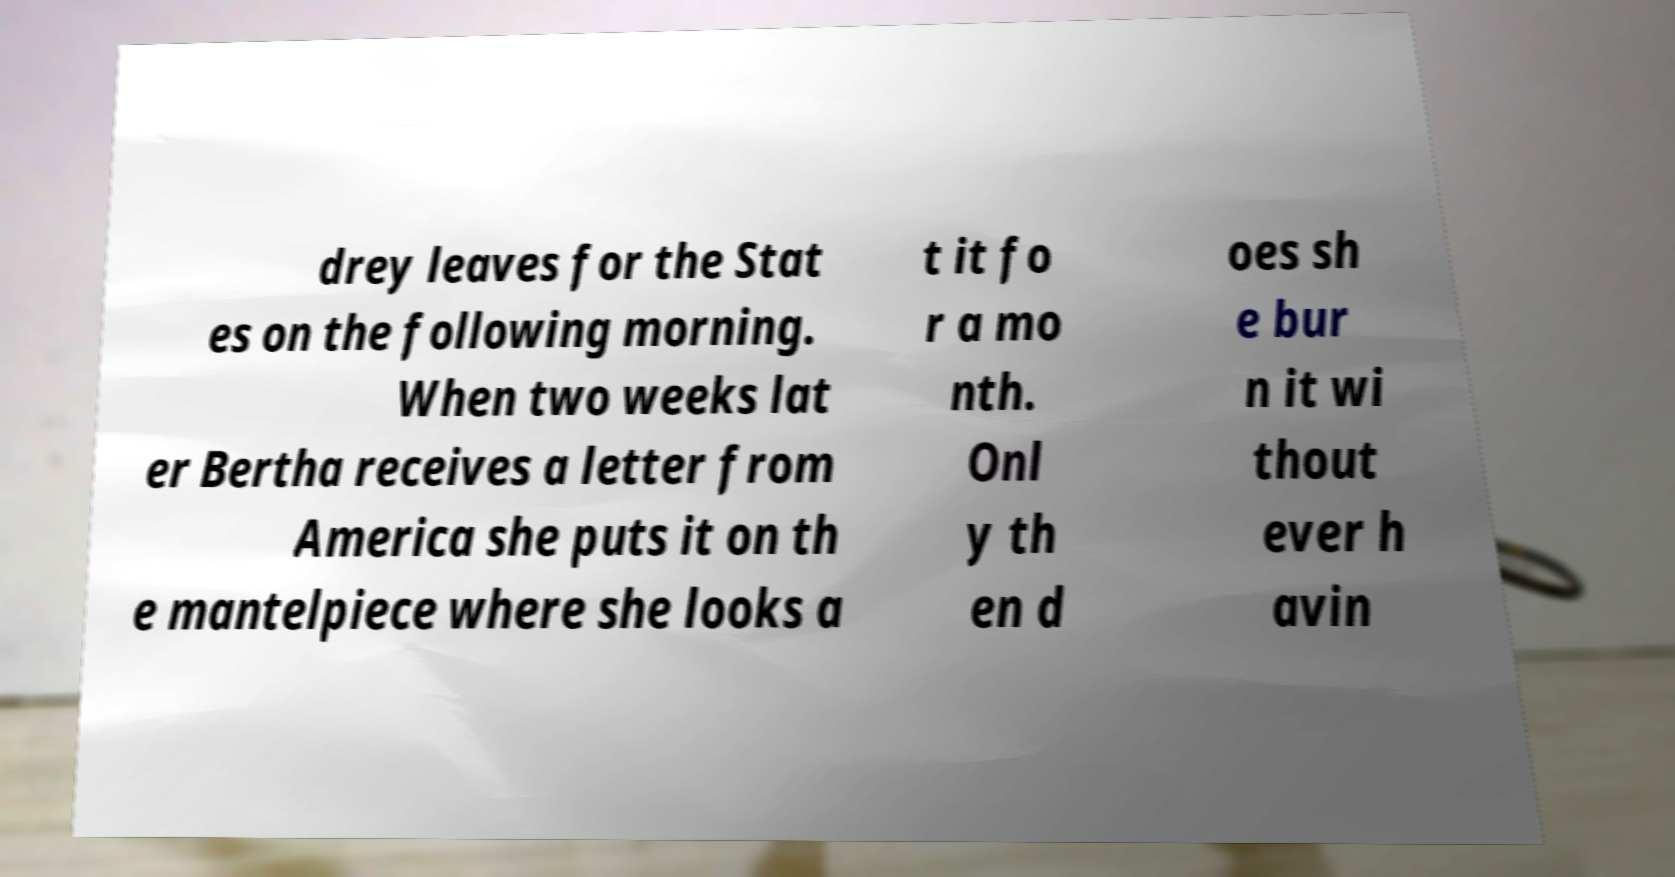Can you accurately transcribe the text from the provided image for me? drey leaves for the Stat es on the following morning. When two weeks lat er Bertha receives a letter from America she puts it on th e mantelpiece where she looks a t it fo r a mo nth. Onl y th en d oes sh e bur n it wi thout ever h avin 